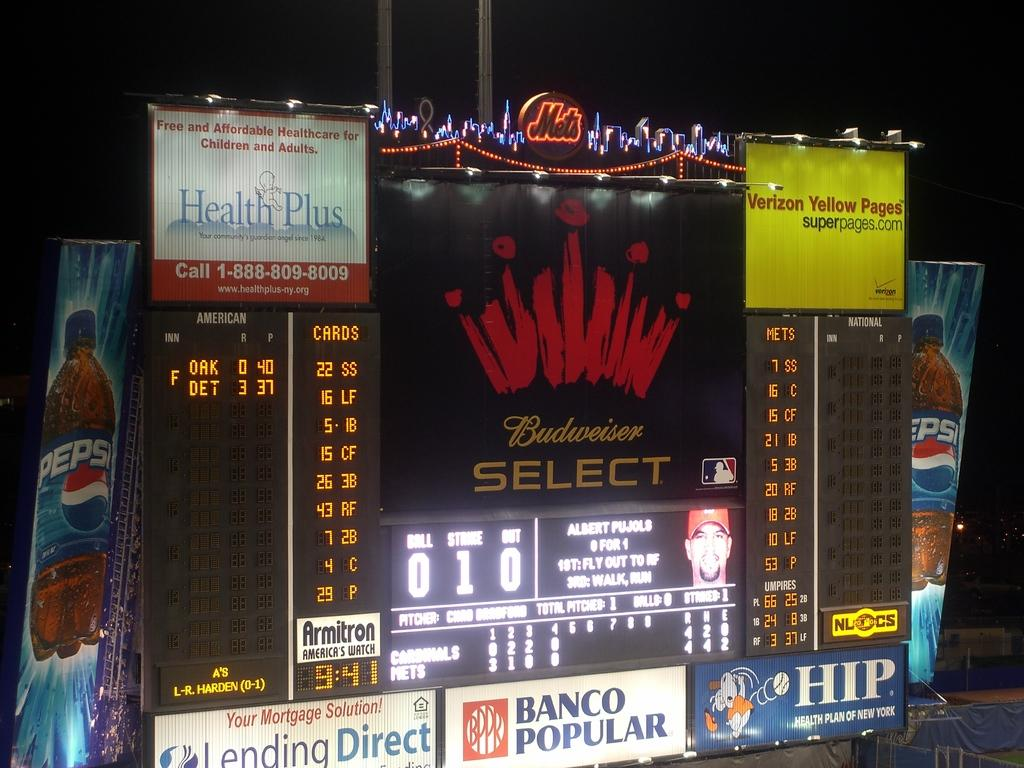<image>
Present a compact description of the photo's key features. a scoreboard that has the words 'budweiser select' on it 